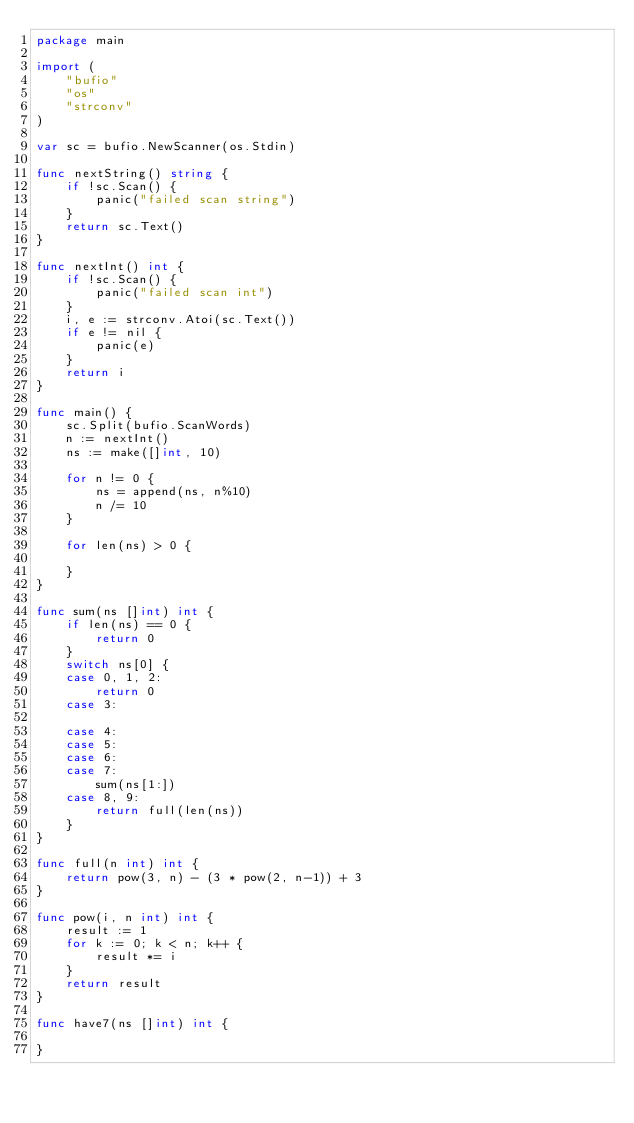Convert code to text. <code><loc_0><loc_0><loc_500><loc_500><_Go_>package main

import (
	"bufio"
	"os"
	"strconv"
)

var sc = bufio.NewScanner(os.Stdin)

func nextString() string {
	if !sc.Scan() {
		panic("failed scan string")
	}
	return sc.Text()
}

func nextInt() int {
	if !sc.Scan() {
		panic("failed scan int")
	}
	i, e := strconv.Atoi(sc.Text())
	if e != nil {
		panic(e)
	}
	return i
}

func main() {
	sc.Split(bufio.ScanWords)
	n := nextInt()
	ns := make([]int, 10)

	for n != 0 {
		ns = append(ns, n%10)
		n /= 10
	}

	for len(ns) > 0 {

	}
}

func sum(ns []int) int {
	if len(ns) == 0 {
		return 0
	}
	switch ns[0] {
	case 0, 1, 2:
		return 0
	case 3:

	case 4:
	case 5:
	case 6:
	case 7:
		sum(ns[1:])
	case 8, 9:
		return full(len(ns))
	}
}

func full(n int) int {
	return pow(3, n) - (3 * pow(2, n-1)) + 3
}

func pow(i, n int) int {
	result := 1
	for k := 0; k < n; k++ {
		result *= i
	}
	return result
}

func have7(ns []int) int {

}
</code> 